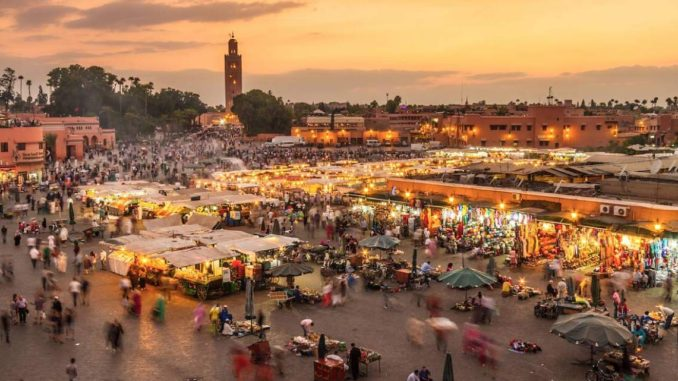Explain the visual content of the image in great detail. The image captures the dynamic and bustling scene of Jemaa El Fnaa, a famous square and marketplace located in the heart of Marrakech, Morocco. Taken from a high vantage point, the viewer gets an expansive view of the square filled with vibrant activities and a plethora of colors. Scattered across the square are numerous tents and stalls, each offering a variety of goods ranging from fresh produce and spices to handmade crafts and textiles. The square is densely populated with people walking, shopping, and conversing, adding to the lively and spirited atmosphere. Illuminated by the soft, warm hues of the setting sun, the scene is bathed in a golden-orange light that enriches the vibrancy of the colors and the lively ambiance. In the background stands the imposing Koutoubia Mosque, with its tall minaret silhouetted against the twilight sky, adding a touch of historical and cultural depth to the view. The mosque’s presence anchors the scene, blending the bustling modern market life with the rich heritage of the city. 